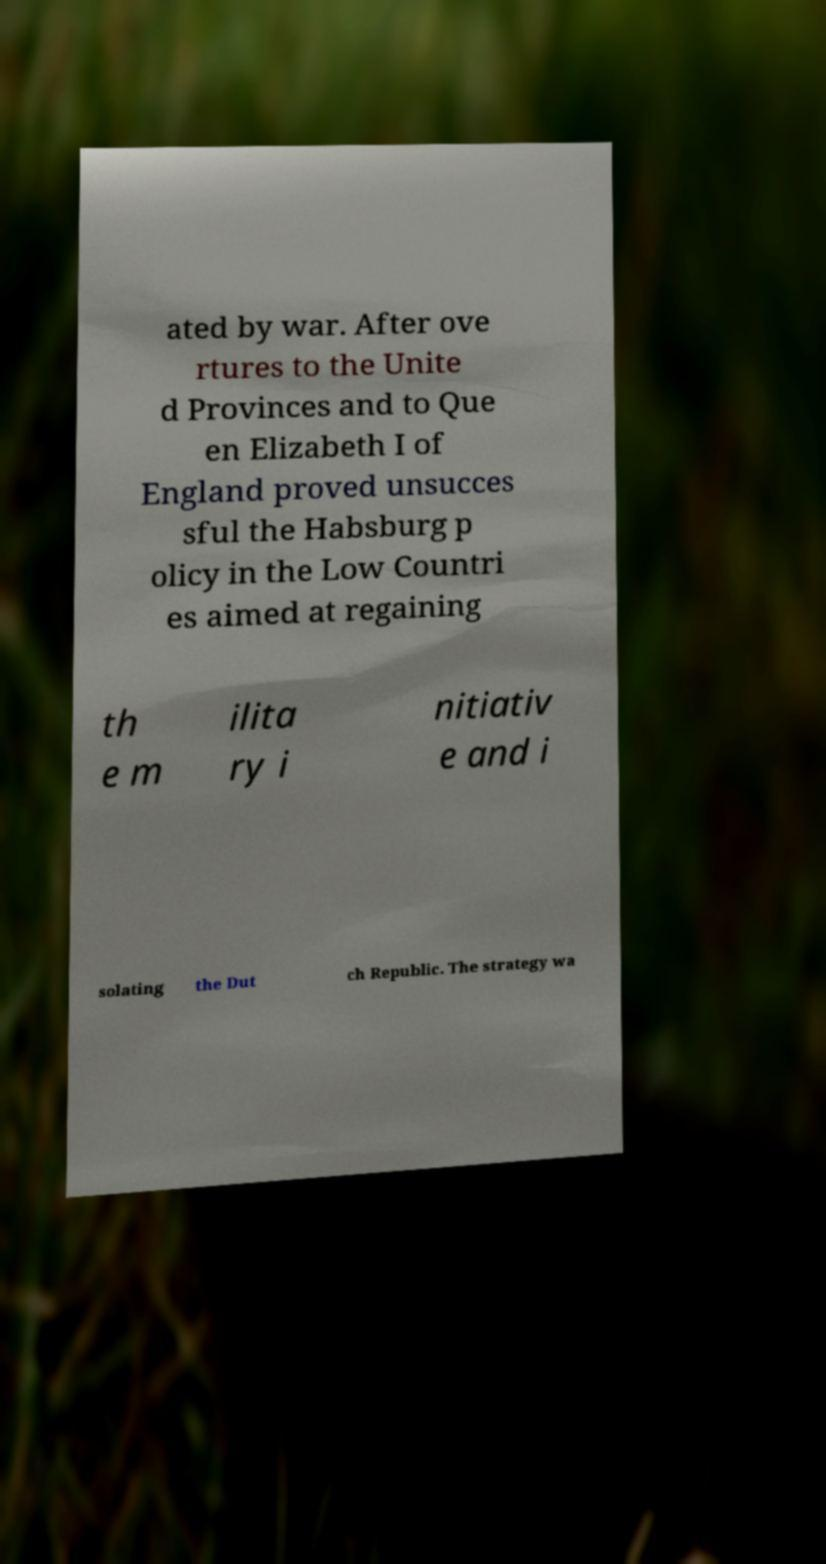What messages or text are displayed in this image? I need them in a readable, typed format. ated by war. After ove rtures to the Unite d Provinces and to Que en Elizabeth I of England proved unsucces sful the Habsburg p olicy in the Low Countri es aimed at regaining th e m ilita ry i nitiativ e and i solating the Dut ch Republic. The strategy wa 